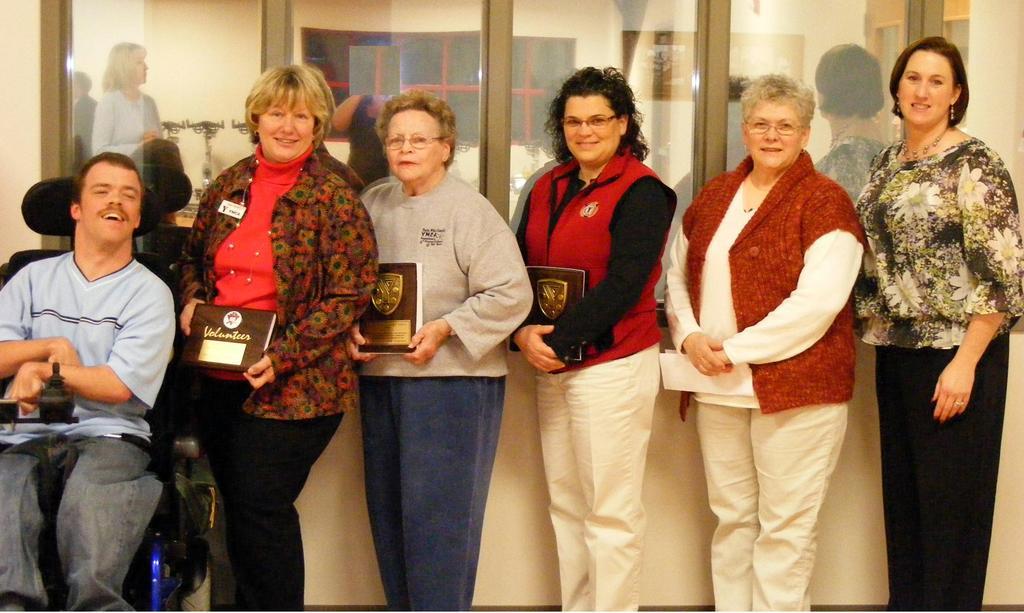Can you describe this image briefly? There is a group of persons standing as we can see in the middle of this image. The persons standing in the middle is holding some books. There is one person sitting on the left side. There is a glass wall in the background. 